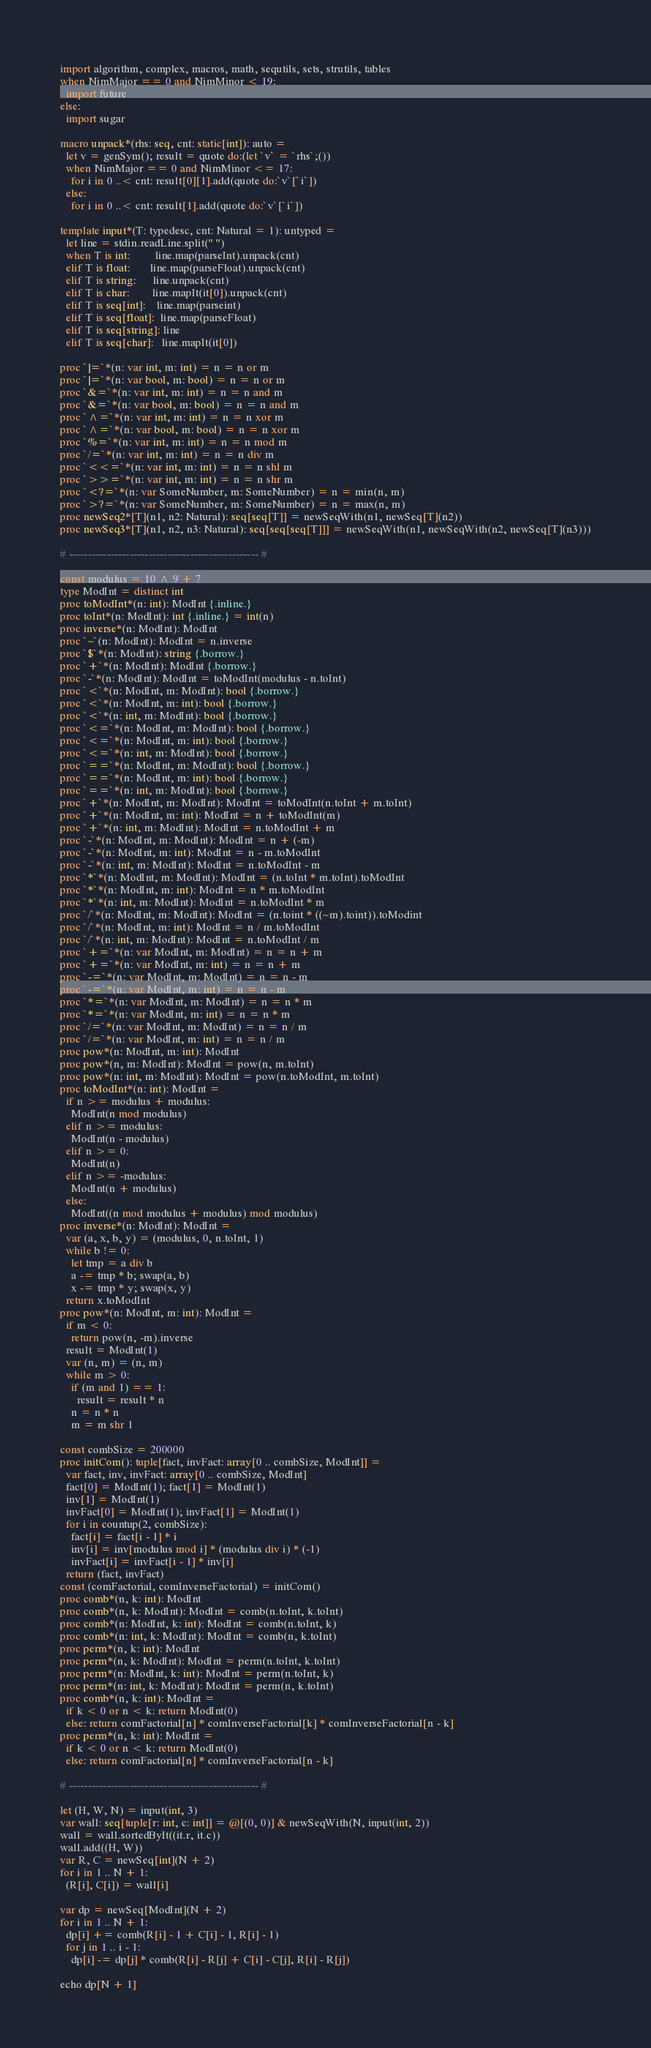<code> <loc_0><loc_0><loc_500><loc_500><_Nim_>import algorithm, complex, macros, math, sequtils, sets, strutils, tables
when NimMajor == 0 and NimMinor < 19:
  import future
else:
  import sugar

macro unpack*(rhs: seq, cnt: static[int]): auto =
  let v = genSym(); result = quote do:(let `v` = `rhs`;())
  when NimMajor == 0 and NimMinor <= 17:
    for i in 0 ..< cnt: result[0][1].add(quote do:`v`[`i`])
  else:
    for i in 0 ..< cnt: result[1].add(quote do:`v`[`i`])

template input*(T: typedesc, cnt: Natural = 1): untyped =
  let line = stdin.readLine.split(" ")
  when T is int:         line.map(parseInt).unpack(cnt)
  elif T is float:       line.map(parseFloat).unpack(cnt)
  elif T is string:      line.unpack(cnt)
  elif T is char:        line.mapIt(it[0]).unpack(cnt)
  elif T is seq[int]:    line.map(parseint)
  elif T is seq[float]:  line.map(parseFloat)
  elif T is seq[string]: line
  elif T is seq[char]:   line.mapIt(it[0])

proc `|=`*(n: var int, m: int) = n = n or m
proc `|=`*(n: var bool, m: bool) = n = n or m
proc `&=`*(n: var int, m: int) = n = n and m
proc `&=`*(n: var bool, m: bool) = n = n and m
proc `^=`*(n: var int, m: int) = n = n xor m
proc `^=`*(n: var bool, m: bool) = n = n xor m
proc `%=`*(n: var int, m: int) = n = n mod m
proc `/=`*(n: var int, m: int) = n = n div m
proc `<<=`*(n: var int, m: int) = n = n shl m
proc `>>=`*(n: var int, m: int) = n = n shr m
proc `<?=`*(n: var SomeNumber, m: SomeNumber) = n = min(n, m)
proc `>?=`*(n: var SomeNumber, m: SomeNumber) = n = max(n, m)
proc newSeq2*[T](n1, n2: Natural): seq[seq[T]] = newSeqWith(n1, newSeq[T](n2))
proc newSeq3*[T](n1, n2, n3: Natural): seq[seq[seq[T]]] = newSeqWith(n1, newSeqWith(n2, newSeq[T](n3)))

# -------------------------------------------------- #

const modulus = 10 ^ 9 + 7
type ModInt = distinct int
proc toModInt*(n: int): ModInt {.inline.}
proc toInt*(n: ModInt): int {.inline.} = int(n)
proc inverse*(n: ModInt): ModInt
proc `~`(n: ModInt): ModInt = n.inverse
proc `$`*(n: ModInt): string {.borrow.}
proc `+`*(n: ModInt): ModInt {.borrow.}
proc `-`*(n: ModInt): ModInt = toModInt(modulus - n.toInt)
proc `<`*(n: ModInt, m: ModInt): bool {.borrow.}
proc `<`*(n: ModInt, m: int): bool {.borrow.}
proc `<`*(n: int, m: ModInt): bool {.borrow.}
proc `<=`*(n: ModInt, m: ModInt): bool {.borrow.}
proc `<=`*(n: ModInt, m: int): bool {.borrow.}
proc `<=`*(n: int, m: ModInt): bool {.borrow.}
proc `==`*(n: ModInt, m: ModInt): bool {.borrow.}
proc `==`*(n: ModInt, m: int): bool {.borrow.}
proc `==`*(n: int, m: ModInt): bool {.borrow.}
proc `+`*(n: ModInt, m: ModInt): ModInt = toModInt(n.toInt + m.toInt)
proc `+`*(n: ModInt, m: int): ModInt = n + toModInt(m)
proc `+`*(n: int, m: ModInt): ModInt = n.toModInt + m
proc `-`*(n: ModInt, m: ModInt): ModInt = n + (-m)
proc `-`*(n: ModInt, m: int): ModInt = n - m.toModInt
proc `-`*(n: int, m: ModInt): ModInt = n.toModInt - m
proc `*`*(n: ModInt, m: ModInt): ModInt = (n.toInt * m.toInt).toModInt
proc `*`*(n: ModInt, m: int): ModInt = n * m.toModInt
proc `*`*(n: int, m: ModInt): ModInt = n.toModInt * m
proc `/`*(n: ModInt, m: ModInt): ModInt = (n.toint * ((~m).toint)).toModint
proc `/`*(n: ModInt, m: int): ModInt = n / m.toModInt
proc `/`*(n: int, m: ModInt): ModInt = n.toModInt / m
proc `+=`*(n: var ModInt, m: ModInt) = n = n + m
proc `+=`*(n: var ModInt, m: int) = n = n + m
proc `-=`*(n: var ModInt, m: ModInt) = n = n - m
proc `-=`*(n: var ModInt, m: int) = n = n - m
proc `*=`*(n: var ModInt, m: ModInt) = n = n * m
proc `*=`*(n: var ModInt, m: int) = n = n * m
proc `/=`*(n: var ModInt, m: ModInt) = n = n / m
proc `/=`*(n: var ModInt, m: int) = n = n / m
proc pow*(n: ModInt, m: int): ModInt
proc pow*(n, m: ModInt): ModInt = pow(n, m.toInt)
proc pow*(n: int, m: ModInt): ModInt = pow(n.toModInt, m.toInt)
proc toModInt*(n: int): ModInt =
  if n >= modulus + modulus:
    ModInt(n mod modulus)
  elif n >= modulus:
    ModInt(n - modulus)
  elif n >= 0:
    ModInt(n)
  elif n >= -modulus:
    ModInt(n + modulus)
  else:
    ModInt((n mod modulus + modulus) mod modulus)
proc inverse*(n: ModInt): ModInt =
  var (a, x, b, y) = (modulus, 0, n.toInt, 1)
  while b != 0:
    let tmp = a div b
    a -= tmp * b; swap(a, b)
    x -= tmp * y; swap(x, y)
  return x.toModInt
proc pow*(n: ModInt, m: int): ModInt =
  if m < 0:
    return pow(n, -m).inverse
  result = ModInt(1)
  var (n, m) = (n, m)
  while m > 0:
    if (m and 1) == 1:
      result = result * n
    n = n * n
    m = m shr 1

const combSize = 200000
proc initCom(): tuple[fact, invFact: array[0 .. combSize, ModInt]] =
  var fact, inv, invFact: array[0 .. combSize, ModInt]
  fact[0] = ModInt(1); fact[1] = ModInt(1)
  inv[1] = ModInt(1)
  invFact[0] = ModInt(1); invFact[1] = ModInt(1)
  for i in countup(2, combSize):
    fact[i] = fact[i - 1] * i
    inv[i] = inv[modulus mod i] * (modulus div i) * (-1)
    invFact[i] = invFact[i - 1] * inv[i]
  return (fact, invFact)
const (comFactorial, comInverseFactorial) = initCom()
proc comb*(n, k: int): ModInt
proc comb*(n, k: ModInt): ModInt = comb(n.toInt, k.toInt)
proc comb*(n: ModInt, k: int): ModInt = comb(n.toInt, k)
proc comb*(n: int, k: ModInt): ModInt = comb(n, k.toInt)
proc perm*(n, k: int): ModInt
proc perm*(n, k: ModInt): ModInt = perm(n.toInt, k.toInt)
proc perm*(n: ModInt, k: int): ModInt = perm(n.toInt, k)
proc perm*(n: int, k: ModInt): ModInt = perm(n, k.toInt)
proc comb*(n, k: int): ModInt =
  if k < 0 or n < k: return ModInt(0)
  else: return comFactorial[n] * comInverseFactorial[k] * comInverseFactorial[n - k]
proc perm*(n, k: int): ModInt =
  if k < 0 or n < k: return ModInt(0)
  else: return comFactorial[n] * comInverseFactorial[n - k]

# -------------------------------------------------- #

let (H, W, N) = input(int, 3)
var wall: seq[tuple[r: int, c: int]] = @[(0, 0)] & newSeqWith(N, input(int, 2))
wall = wall.sortedByIt((it.r, it.c))
wall.add((H, W))
var R, C = newSeq[int](N + 2)
for i in 1 .. N + 1:
  (R[i], C[i]) = wall[i]

var dp = newSeq[ModInt](N + 2)
for i in 1 .. N + 1:
  dp[i] += comb(R[i] - 1 + C[i] - 1, R[i] - 1)
  for j in 1 .. i - 1:
    dp[i] -= dp[j] * comb(R[i] - R[j] + C[i] - C[j], R[i] - R[j])

echo dp[N + 1]</code> 